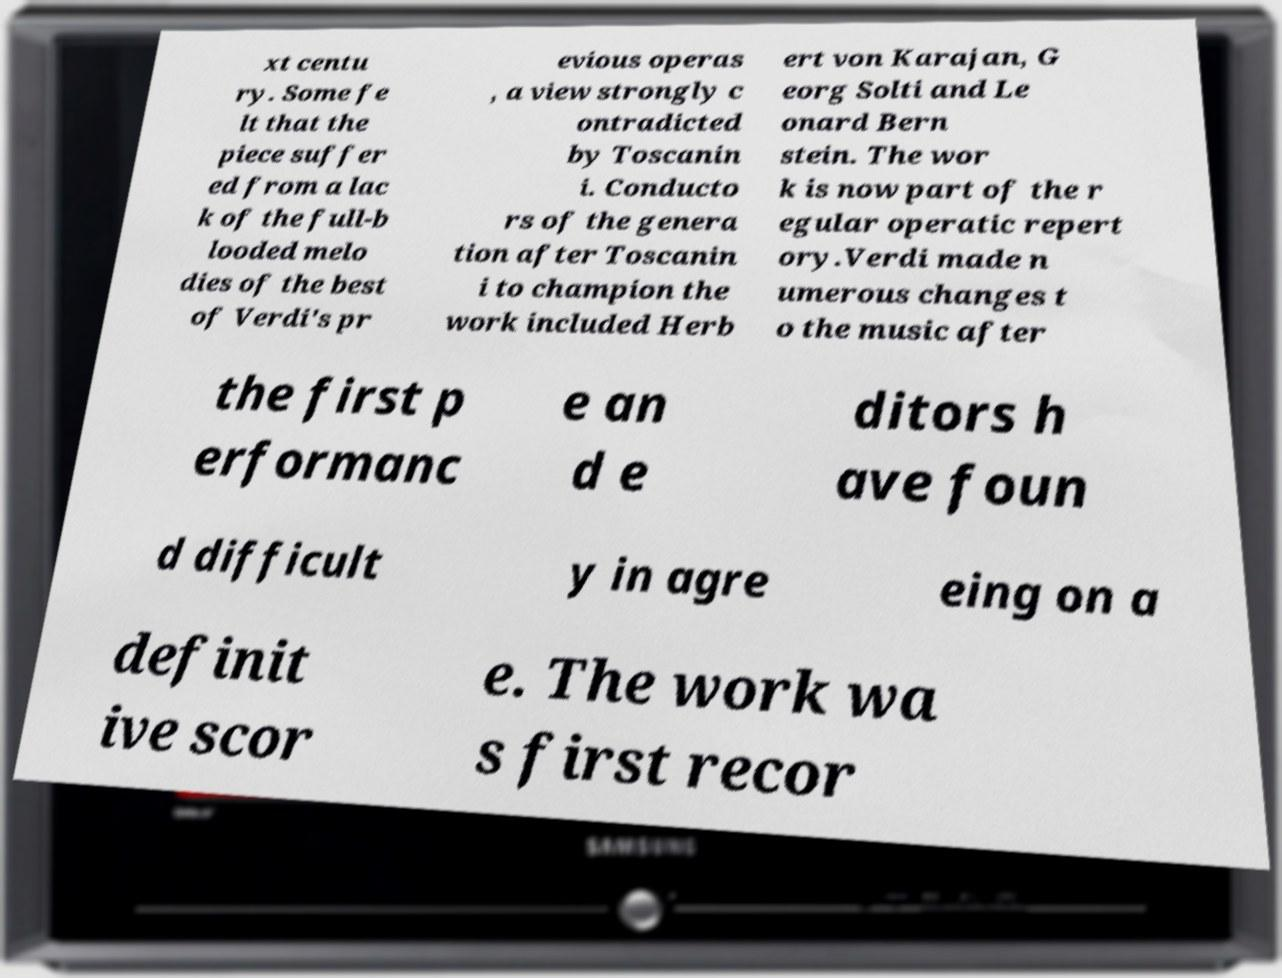Could you extract and type out the text from this image? xt centu ry. Some fe lt that the piece suffer ed from a lac k of the full-b looded melo dies of the best of Verdi's pr evious operas , a view strongly c ontradicted by Toscanin i. Conducto rs of the genera tion after Toscanin i to champion the work included Herb ert von Karajan, G eorg Solti and Le onard Bern stein. The wor k is now part of the r egular operatic repert ory.Verdi made n umerous changes t o the music after the first p erformanc e an d e ditors h ave foun d difficult y in agre eing on a definit ive scor e. The work wa s first recor 